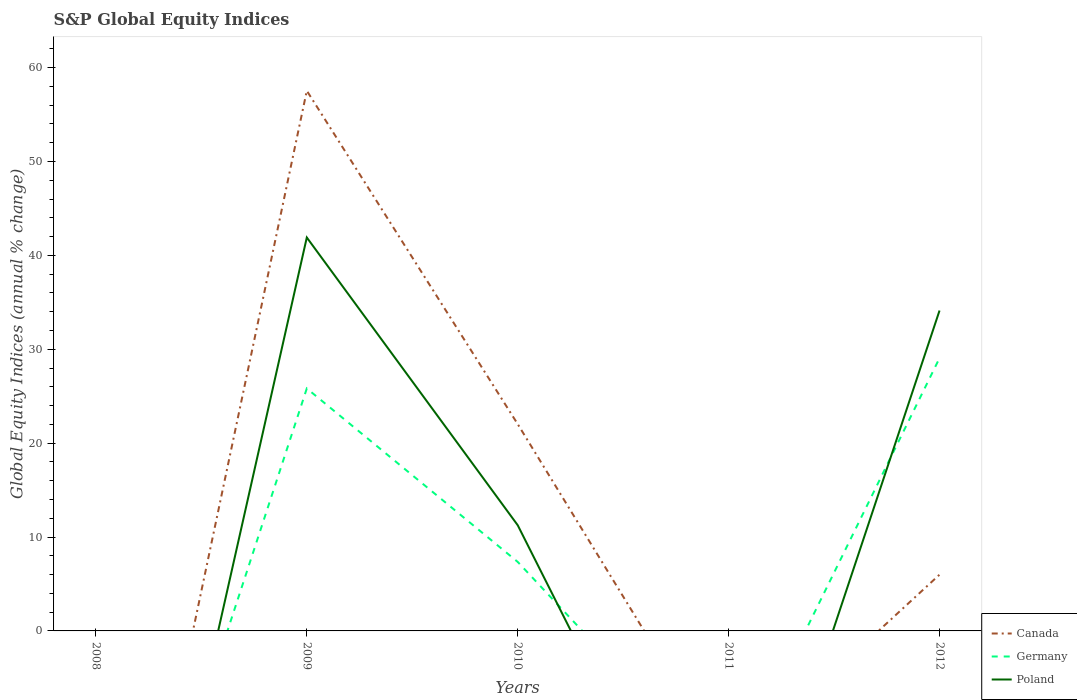How many different coloured lines are there?
Provide a succinct answer. 3. What is the total global equity indices in Germany in the graph?
Provide a short and direct response. -3.24. What is the difference between the highest and the second highest global equity indices in Germany?
Make the answer very short. 29.06. What is the difference between the highest and the lowest global equity indices in Poland?
Offer a very short reply. 2. How many lines are there?
Provide a short and direct response. 3. How many years are there in the graph?
Your response must be concise. 5. What is the difference between two consecutive major ticks on the Y-axis?
Give a very brief answer. 10. Are the values on the major ticks of Y-axis written in scientific E-notation?
Your response must be concise. No. Does the graph contain any zero values?
Offer a terse response. Yes. Does the graph contain grids?
Your answer should be very brief. No. Where does the legend appear in the graph?
Offer a very short reply. Bottom right. How are the legend labels stacked?
Your answer should be very brief. Vertical. What is the title of the graph?
Offer a very short reply. S&P Global Equity Indices. What is the label or title of the X-axis?
Ensure brevity in your answer.  Years. What is the label or title of the Y-axis?
Your response must be concise. Global Equity Indices (annual % change). What is the Global Equity Indices (annual % change) in Poland in 2008?
Ensure brevity in your answer.  0. What is the Global Equity Indices (annual % change) in Canada in 2009?
Keep it short and to the point. 57.53. What is the Global Equity Indices (annual % change) of Germany in 2009?
Your answer should be very brief. 25.82. What is the Global Equity Indices (annual % change) in Poland in 2009?
Offer a terse response. 41.9. What is the Global Equity Indices (annual % change) in Canada in 2010?
Ensure brevity in your answer.  22.03. What is the Global Equity Indices (annual % change) of Germany in 2010?
Make the answer very short. 7.35. What is the Global Equity Indices (annual % change) in Poland in 2010?
Your answer should be very brief. 11.26. What is the Global Equity Indices (annual % change) in Canada in 2011?
Ensure brevity in your answer.  0. What is the Global Equity Indices (annual % change) in Germany in 2011?
Your answer should be compact. 0. What is the Global Equity Indices (annual % change) of Canada in 2012?
Your response must be concise. 5.99. What is the Global Equity Indices (annual % change) of Germany in 2012?
Make the answer very short. 29.06. What is the Global Equity Indices (annual % change) of Poland in 2012?
Your answer should be compact. 34.12. Across all years, what is the maximum Global Equity Indices (annual % change) of Canada?
Your answer should be compact. 57.53. Across all years, what is the maximum Global Equity Indices (annual % change) of Germany?
Your answer should be very brief. 29.06. Across all years, what is the maximum Global Equity Indices (annual % change) of Poland?
Make the answer very short. 41.9. Across all years, what is the minimum Global Equity Indices (annual % change) in Canada?
Provide a short and direct response. 0. What is the total Global Equity Indices (annual % change) in Canada in the graph?
Offer a very short reply. 85.55. What is the total Global Equity Indices (annual % change) of Germany in the graph?
Provide a succinct answer. 62.23. What is the total Global Equity Indices (annual % change) of Poland in the graph?
Give a very brief answer. 87.28. What is the difference between the Global Equity Indices (annual % change) in Canada in 2009 and that in 2010?
Ensure brevity in your answer.  35.51. What is the difference between the Global Equity Indices (annual % change) of Germany in 2009 and that in 2010?
Make the answer very short. 18.47. What is the difference between the Global Equity Indices (annual % change) of Poland in 2009 and that in 2010?
Your response must be concise. 30.64. What is the difference between the Global Equity Indices (annual % change) of Canada in 2009 and that in 2012?
Provide a succinct answer. 51.54. What is the difference between the Global Equity Indices (annual % change) in Germany in 2009 and that in 2012?
Give a very brief answer. -3.24. What is the difference between the Global Equity Indices (annual % change) in Poland in 2009 and that in 2012?
Offer a terse response. 7.78. What is the difference between the Global Equity Indices (annual % change) in Canada in 2010 and that in 2012?
Keep it short and to the point. 16.03. What is the difference between the Global Equity Indices (annual % change) of Germany in 2010 and that in 2012?
Your answer should be compact. -21.71. What is the difference between the Global Equity Indices (annual % change) of Poland in 2010 and that in 2012?
Offer a terse response. -22.86. What is the difference between the Global Equity Indices (annual % change) in Canada in 2009 and the Global Equity Indices (annual % change) in Germany in 2010?
Keep it short and to the point. 50.18. What is the difference between the Global Equity Indices (annual % change) of Canada in 2009 and the Global Equity Indices (annual % change) of Poland in 2010?
Make the answer very short. 46.27. What is the difference between the Global Equity Indices (annual % change) in Germany in 2009 and the Global Equity Indices (annual % change) in Poland in 2010?
Your response must be concise. 14.57. What is the difference between the Global Equity Indices (annual % change) in Canada in 2009 and the Global Equity Indices (annual % change) in Germany in 2012?
Offer a terse response. 28.47. What is the difference between the Global Equity Indices (annual % change) of Canada in 2009 and the Global Equity Indices (annual % change) of Poland in 2012?
Make the answer very short. 23.41. What is the difference between the Global Equity Indices (annual % change) in Germany in 2009 and the Global Equity Indices (annual % change) in Poland in 2012?
Offer a terse response. -8.3. What is the difference between the Global Equity Indices (annual % change) of Canada in 2010 and the Global Equity Indices (annual % change) of Germany in 2012?
Provide a succinct answer. -7.03. What is the difference between the Global Equity Indices (annual % change) in Canada in 2010 and the Global Equity Indices (annual % change) in Poland in 2012?
Your answer should be very brief. -12.1. What is the difference between the Global Equity Indices (annual % change) of Germany in 2010 and the Global Equity Indices (annual % change) of Poland in 2012?
Your response must be concise. -26.77. What is the average Global Equity Indices (annual % change) of Canada per year?
Ensure brevity in your answer.  17.11. What is the average Global Equity Indices (annual % change) in Germany per year?
Provide a short and direct response. 12.45. What is the average Global Equity Indices (annual % change) of Poland per year?
Keep it short and to the point. 17.46. In the year 2009, what is the difference between the Global Equity Indices (annual % change) in Canada and Global Equity Indices (annual % change) in Germany?
Your response must be concise. 31.71. In the year 2009, what is the difference between the Global Equity Indices (annual % change) of Canada and Global Equity Indices (annual % change) of Poland?
Provide a succinct answer. 15.63. In the year 2009, what is the difference between the Global Equity Indices (annual % change) of Germany and Global Equity Indices (annual % change) of Poland?
Keep it short and to the point. -16.08. In the year 2010, what is the difference between the Global Equity Indices (annual % change) in Canada and Global Equity Indices (annual % change) in Germany?
Give a very brief answer. 14.68. In the year 2010, what is the difference between the Global Equity Indices (annual % change) in Canada and Global Equity Indices (annual % change) in Poland?
Your response must be concise. 10.77. In the year 2010, what is the difference between the Global Equity Indices (annual % change) of Germany and Global Equity Indices (annual % change) of Poland?
Keep it short and to the point. -3.91. In the year 2012, what is the difference between the Global Equity Indices (annual % change) of Canada and Global Equity Indices (annual % change) of Germany?
Give a very brief answer. -23.07. In the year 2012, what is the difference between the Global Equity Indices (annual % change) in Canada and Global Equity Indices (annual % change) in Poland?
Ensure brevity in your answer.  -28.13. In the year 2012, what is the difference between the Global Equity Indices (annual % change) in Germany and Global Equity Indices (annual % change) in Poland?
Give a very brief answer. -5.06. What is the ratio of the Global Equity Indices (annual % change) in Canada in 2009 to that in 2010?
Offer a terse response. 2.61. What is the ratio of the Global Equity Indices (annual % change) in Germany in 2009 to that in 2010?
Give a very brief answer. 3.51. What is the ratio of the Global Equity Indices (annual % change) in Poland in 2009 to that in 2010?
Your answer should be very brief. 3.72. What is the ratio of the Global Equity Indices (annual % change) of Canada in 2009 to that in 2012?
Make the answer very short. 9.6. What is the ratio of the Global Equity Indices (annual % change) in Germany in 2009 to that in 2012?
Give a very brief answer. 0.89. What is the ratio of the Global Equity Indices (annual % change) of Poland in 2009 to that in 2012?
Make the answer very short. 1.23. What is the ratio of the Global Equity Indices (annual % change) in Canada in 2010 to that in 2012?
Your response must be concise. 3.68. What is the ratio of the Global Equity Indices (annual % change) in Germany in 2010 to that in 2012?
Keep it short and to the point. 0.25. What is the ratio of the Global Equity Indices (annual % change) in Poland in 2010 to that in 2012?
Ensure brevity in your answer.  0.33. What is the difference between the highest and the second highest Global Equity Indices (annual % change) in Canada?
Your response must be concise. 35.51. What is the difference between the highest and the second highest Global Equity Indices (annual % change) in Germany?
Keep it short and to the point. 3.24. What is the difference between the highest and the second highest Global Equity Indices (annual % change) in Poland?
Offer a very short reply. 7.78. What is the difference between the highest and the lowest Global Equity Indices (annual % change) of Canada?
Provide a short and direct response. 57.53. What is the difference between the highest and the lowest Global Equity Indices (annual % change) of Germany?
Offer a terse response. 29.06. What is the difference between the highest and the lowest Global Equity Indices (annual % change) in Poland?
Offer a very short reply. 41.9. 